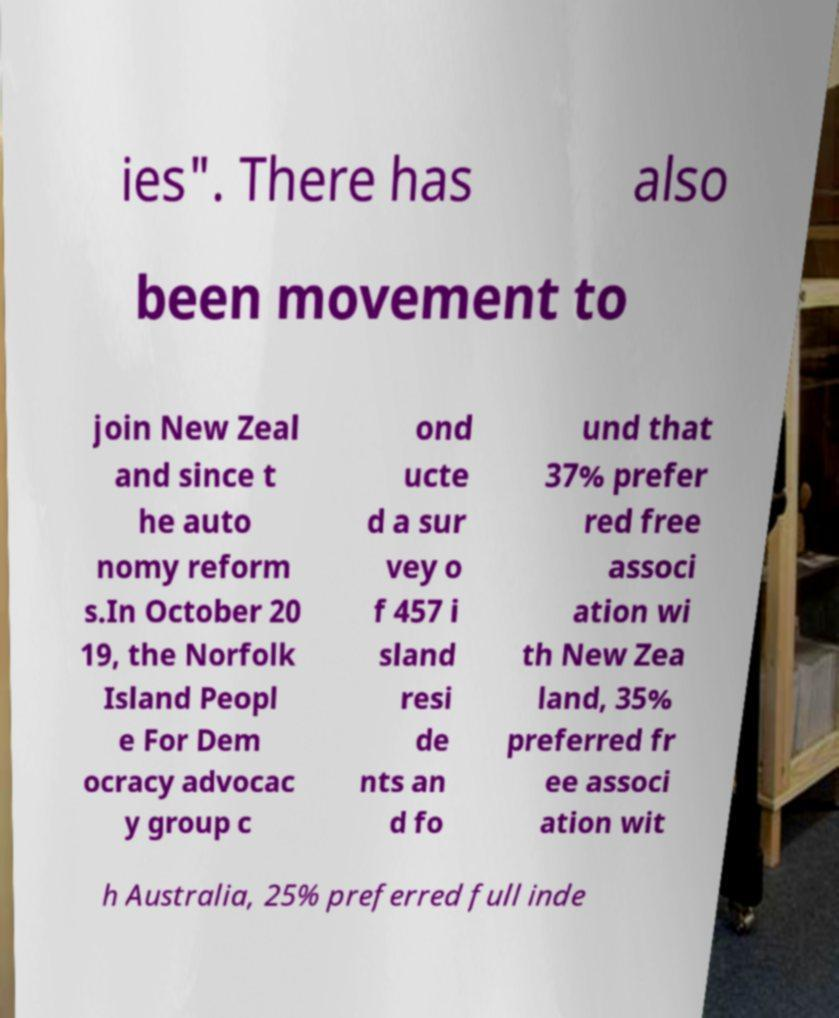Please identify and transcribe the text found in this image. ies". There has also been movement to join New Zeal and since t he auto nomy reform s.In October 20 19, the Norfolk Island Peopl e For Dem ocracy advocac y group c ond ucte d a sur vey o f 457 i sland resi de nts an d fo und that 37% prefer red free associ ation wi th New Zea land, 35% preferred fr ee associ ation wit h Australia, 25% preferred full inde 